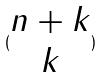<formula> <loc_0><loc_0><loc_500><loc_500>( \begin{matrix} n + k \\ k \end{matrix} )</formula> 